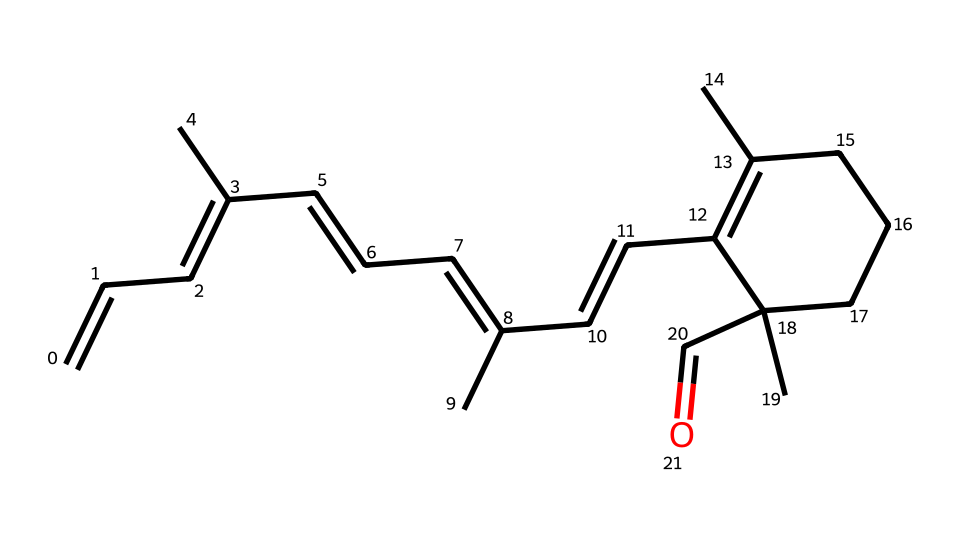What type of isomerism does this compound exhibit? The chemical structure contains multiple double bonds and substituents can be oriented differently around these bonds, indicating the presence of geometric isomerism.
Answer: geometric isomerism How many double bonds are present in the structure? By analyzing the SMILES representation, you can identify each double bond indicated by "="; there are a total of five double bonds in this structure.
Answer: five What is the functional group present in this compound? The presence of the carbonyl (C=O) group at the end of the structure signifies that the compound contains an aldehyde functional group.
Answer: aldehyde Are there cis and trans configurations in this compound? The structure shows different spatial arrangements of substituents around the double bonds, confirming that both cis and trans configurations are present within its geometric isomers.
Answer: yes What is the role of retinal in vision concerning geometric isomerism? Retinal is a visual pigment that changes its structure between cis and trans configurations upon absorbing light, which is critical for the vision process in animals including humans.
Answer: vision In terms of workplace lighting policies, why is understanding isomerism of retinal important? Knowledge of how retinal's isomers respond to light can guide policies to optimize artificial lighting to enhance visual comfort and reduce eye strain, fostering healthier work environments.
Answer: visual comfort 